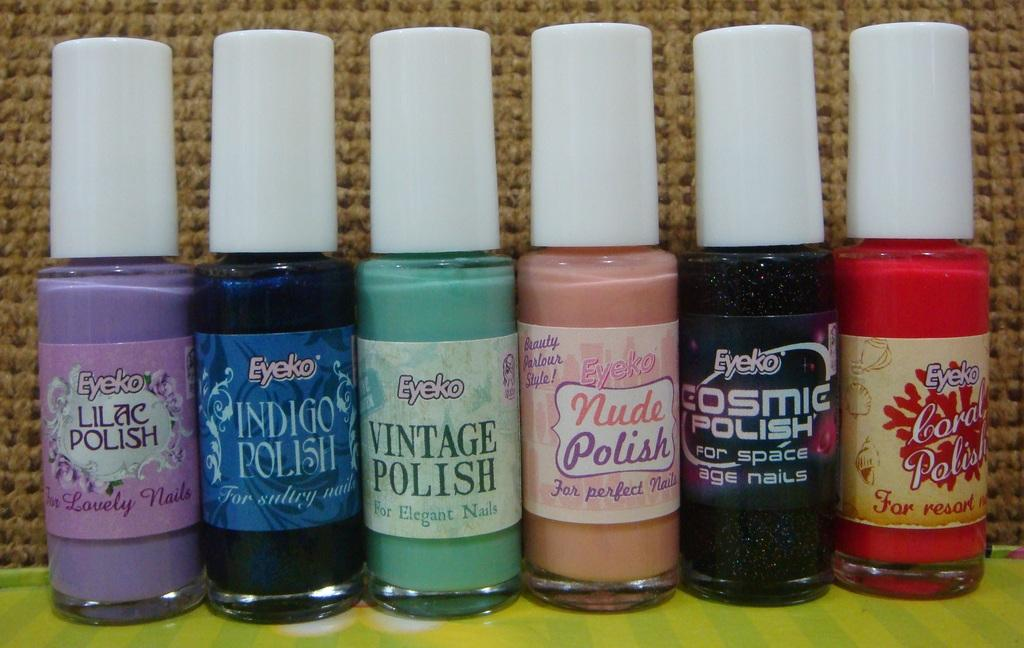What objects are in the foreground of the image? There are nail polishes in the foreground of the image. What color is the surface beneath the nail polishes? The surface beneath the nail polishes is green. What can be seen in the background of the image? There is cloth visible in the background of the image. Where is the crib located in the image? There is no crib present in the image. What type of hat is being worn by the nail polishes in the image? Nail polishes are inanimate objects and cannot wear hats. 